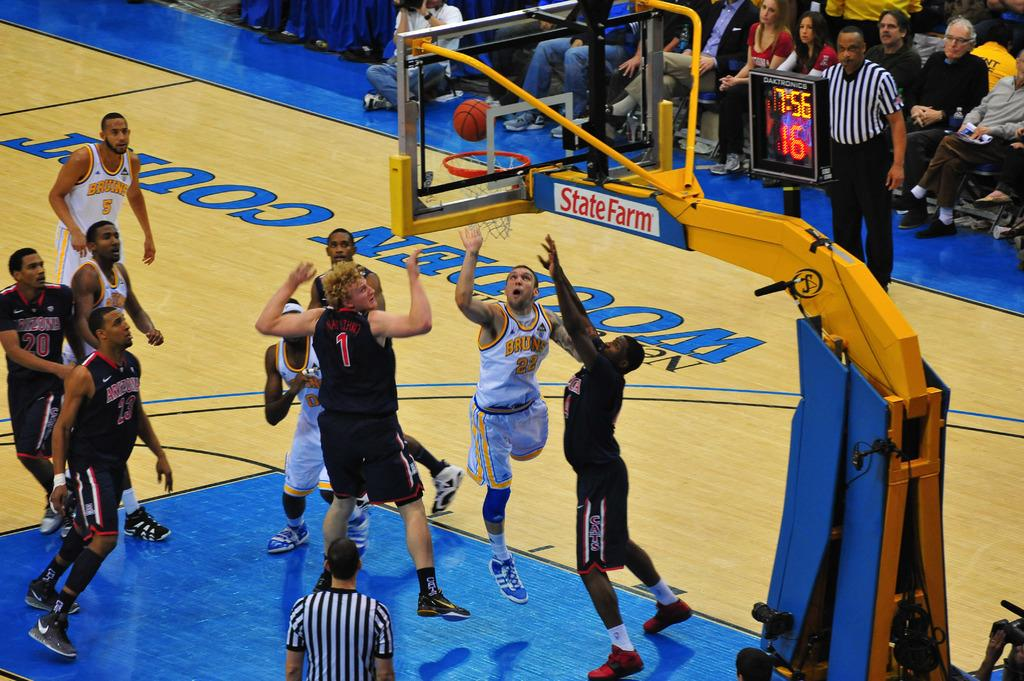<image>
Present a compact description of the photo's key features. men playing basketball on a wooden court with state farm 